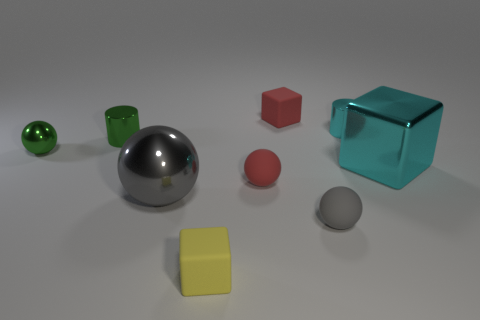What is the shape of the cyan thing left of the metal block?
Your response must be concise. Cylinder. What number of other things are there of the same material as the large cyan cube
Your answer should be compact. 4. What size is the green cylinder?
Ensure brevity in your answer.  Small. What number of other things are the same color as the big metal block?
Provide a short and direct response. 1. What color is the matte object that is both behind the gray matte sphere and on the left side of the tiny red rubber cube?
Ensure brevity in your answer.  Red. How many small gray rubber things are there?
Ensure brevity in your answer.  1. Is the material of the large gray sphere the same as the red cube?
Provide a short and direct response. No. There is a gray thing that is to the right of the gray shiny ball that is in front of the big cyan cube that is to the right of the big gray object; what is its shape?
Provide a succinct answer. Sphere. Does the small cylinder on the left side of the big gray sphere have the same material as the sphere that is to the right of the red matte block?
Your answer should be very brief. No. What material is the yellow object?
Give a very brief answer. Rubber. 